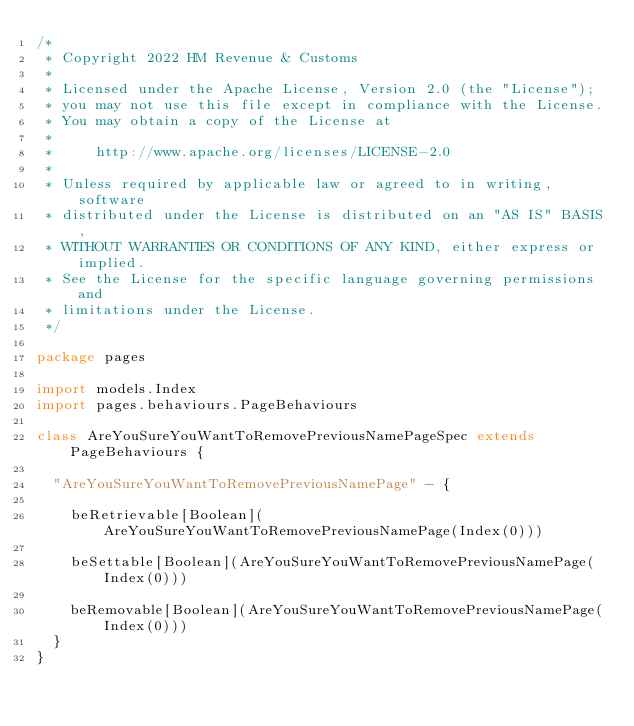<code> <loc_0><loc_0><loc_500><loc_500><_Scala_>/*
 * Copyright 2022 HM Revenue & Customs
 *
 * Licensed under the Apache License, Version 2.0 (the "License");
 * you may not use this file except in compliance with the License.
 * You may obtain a copy of the License at
 *
 *     http://www.apache.org/licenses/LICENSE-2.0
 *
 * Unless required by applicable law or agreed to in writing, software
 * distributed under the License is distributed on an "AS IS" BASIS,
 * WITHOUT WARRANTIES OR CONDITIONS OF ANY KIND, either express or implied.
 * See the License for the specific language governing permissions and
 * limitations under the License.
 */

package pages

import models.Index
import pages.behaviours.PageBehaviours

class AreYouSureYouWantToRemovePreviousNamePageSpec extends PageBehaviours {

  "AreYouSureYouWantToRemovePreviousNamePage" - {

    beRetrievable[Boolean](AreYouSureYouWantToRemovePreviousNamePage(Index(0)))

    beSettable[Boolean](AreYouSureYouWantToRemovePreviousNamePage(Index(0)))

    beRemovable[Boolean](AreYouSureYouWantToRemovePreviousNamePage(Index(0)))
  }
}
</code> 